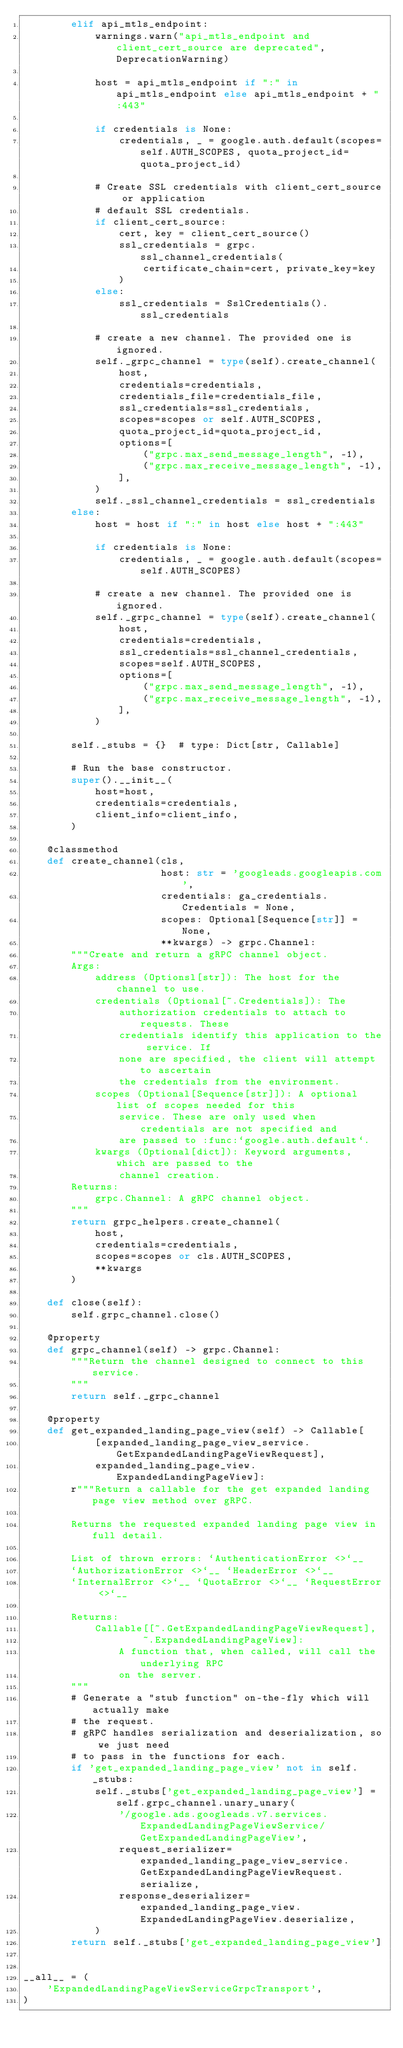<code> <loc_0><loc_0><loc_500><loc_500><_Python_>        elif api_mtls_endpoint:
            warnings.warn("api_mtls_endpoint and client_cert_source are deprecated", DeprecationWarning)

            host = api_mtls_endpoint if ":" in api_mtls_endpoint else api_mtls_endpoint + ":443"

            if credentials is None:
                credentials, _ = google.auth.default(scopes=self.AUTH_SCOPES, quota_project_id=quota_project_id)

            # Create SSL credentials with client_cert_source or application
            # default SSL credentials.
            if client_cert_source:
                cert, key = client_cert_source()
                ssl_credentials = grpc.ssl_channel_credentials(
                    certificate_chain=cert, private_key=key
                )
            else:
                ssl_credentials = SslCredentials().ssl_credentials

            # create a new channel. The provided one is ignored.
            self._grpc_channel = type(self).create_channel(
                host,
                credentials=credentials,
                credentials_file=credentials_file,
                ssl_credentials=ssl_credentials,
                scopes=scopes or self.AUTH_SCOPES,
                quota_project_id=quota_project_id,
                options=[
                    ("grpc.max_send_message_length", -1),
                    ("grpc.max_receive_message_length", -1),
                ],
            )
            self._ssl_channel_credentials = ssl_credentials
        else:
            host = host if ":" in host else host + ":443"

            if credentials is None:
                credentials, _ = google.auth.default(scopes=self.AUTH_SCOPES)

            # create a new channel. The provided one is ignored.
            self._grpc_channel = type(self).create_channel(
                host,
                credentials=credentials,
                ssl_credentials=ssl_channel_credentials,
                scopes=self.AUTH_SCOPES,
                options=[
                    ("grpc.max_send_message_length", -1),
                    ("grpc.max_receive_message_length", -1),
                ],
            )

        self._stubs = {}  # type: Dict[str, Callable]

        # Run the base constructor.
        super().__init__(
            host=host,
            credentials=credentials,
            client_info=client_info,
        )

    @classmethod
    def create_channel(cls,
                       host: str = 'googleads.googleapis.com',
                       credentials: ga_credentials.Credentials = None,
                       scopes: Optional[Sequence[str]] = None,
                       **kwargs) -> grpc.Channel:
        """Create and return a gRPC channel object.
        Args:
            address (Optionsl[str]): The host for the channel to use.
            credentials (Optional[~.Credentials]): The
                authorization credentials to attach to requests. These
                credentials identify this application to the service. If
                none are specified, the client will attempt to ascertain
                the credentials from the environment.
            scopes (Optional[Sequence[str]]): A optional list of scopes needed for this
                service. These are only used when credentials are not specified and
                are passed to :func:`google.auth.default`.
            kwargs (Optional[dict]): Keyword arguments, which are passed to the
                channel creation.
        Returns:
            grpc.Channel: A gRPC channel object.
        """
        return grpc_helpers.create_channel(
            host,
            credentials=credentials,
            scopes=scopes or cls.AUTH_SCOPES,
            **kwargs
        )

    def close(self):
        self.grpc_channel.close()

    @property
    def grpc_channel(self) -> grpc.Channel:
        """Return the channel designed to connect to this service.
        """
        return self._grpc_channel

    @property
    def get_expanded_landing_page_view(self) -> Callable[
            [expanded_landing_page_view_service.GetExpandedLandingPageViewRequest],
            expanded_landing_page_view.ExpandedLandingPageView]:
        r"""Return a callable for the get expanded landing page view method over gRPC.

        Returns the requested expanded landing page view in full detail.

        List of thrown errors: `AuthenticationError <>`__
        `AuthorizationError <>`__ `HeaderError <>`__
        `InternalError <>`__ `QuotaError <>`__ `RequestError <>`__

        Returns:
            Callable[[~.GetExpandedLandingPageViewRequest],
                    ~.ExpandedLandingPageView]:
                A function that, when called, will call the underlying RPC
                on the server.
        """
        # Generate a "stub function" on-the-fly which will actually make
        # the request.
        # gRPC handles serialization and deserialization, so we just need
        # to pass in the functions for each.
        if 'get_expanded_landing_page_view' not in self._stubs:
            self._stubs['get_expanded_landing_page_view'] = self.grpc_channel.unary_unary(
                '/google.ads.googleads.v7.services.ExpandedLandingPageViewService/GetExpandedLandingPageView',
                request_serializer=expanded_landing_page_view_service.GetExpandedLandingPageViewRequest.serialize,
                response_deserializer=expanded_landing_page_view.ExpandedLandingPageView.deserialize,
            )
        return self._stubs['get_expanded_landing_page_view']


__all__ = (
    'ExpandedLandingPageViewServiceGrpcTransport',
)
</code> 